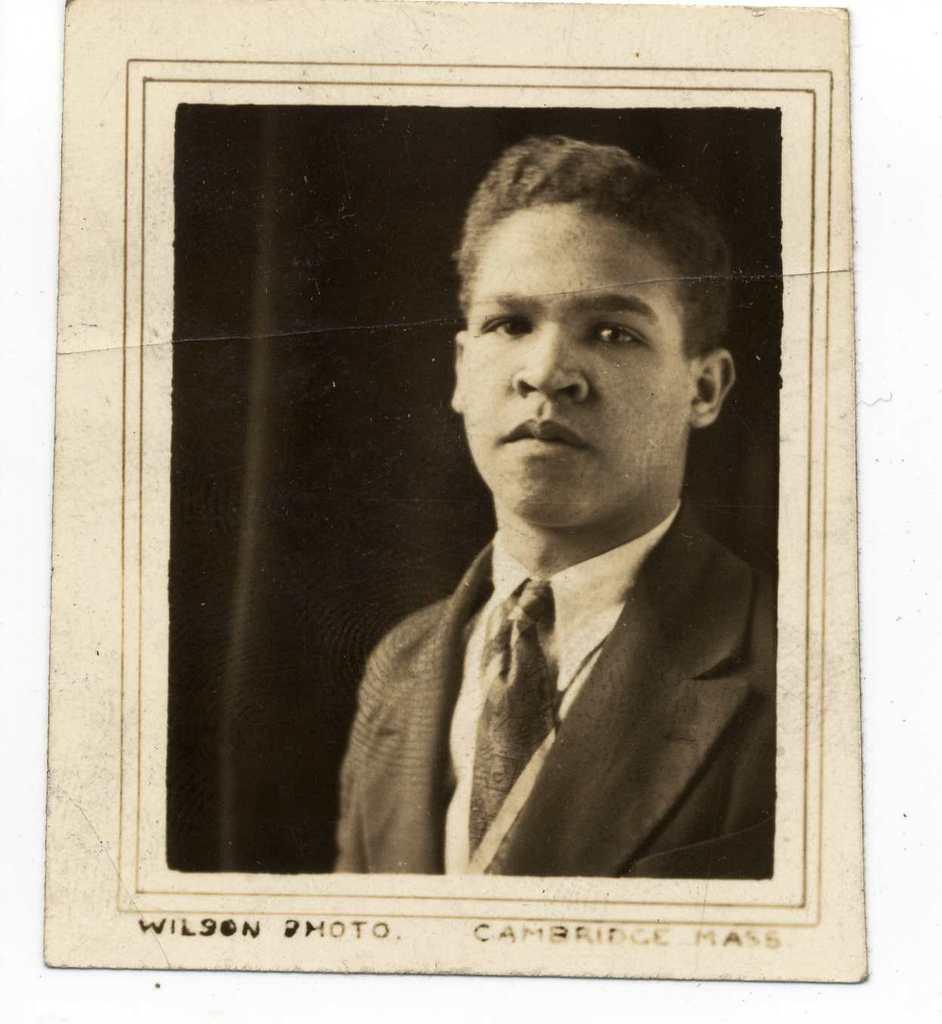What is the color scheme of the image? The image is black and white. Can you describe the person in the image? There is a person on the right side of the image. What else is present at the bottom of the image? There is some text at the bottom of the image. How many feathers can be seen floating in the fog in the image? There is no fog or feathers present in the image; it is a black and white image with a person and text. 